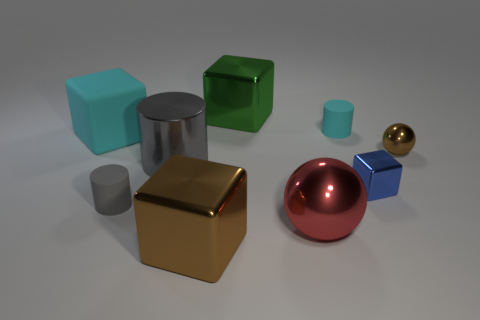Do the metallic cylinder and the small rubber thing in front of the small brown metallic thing have the same color?
Your response must be concise. Yes. What is the shape of the matte thing that is the same color as the big shiny cylinder?
Provide a succinct answer. Cylinder. What is the color of the small thing that is made of the same material as the small cyan cylinder?
Make the answer very short. Gray. Does the large matte object have the same shape as the green shiny thing?
Keep it short and to the point. Yes. Is there a big metallic thing behind the metallic block that is right of the large shiny ball in front of the green metallic object?
Offer a terse response. Yes. What number of small cylinders are the same color as the big matte block?
Provide a succinct answer. 1. There is a red object that is the same size as the green metal thing; what is its shape?
Provide a short and direct response. Sphere. Are there any matte things behind the tiny blue cube?
Give a very brief answer. Yes. Is the size of the matte cube the same as the red ball?
Offer a very short reply. Yes. What is the shape of the tiny rubber object right of the large green cube?
Give a very brief answer. Cylinder. 